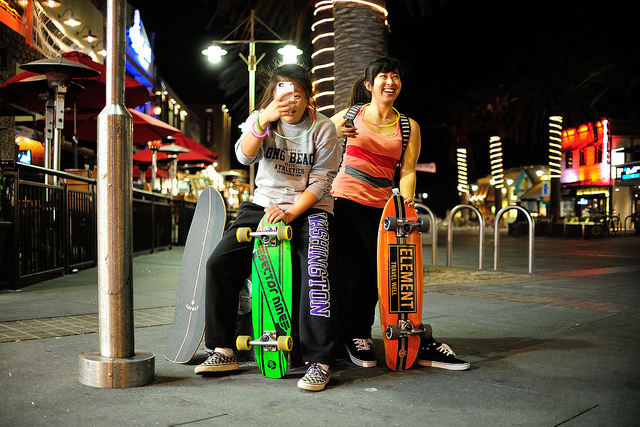Read all the text in this image. ONG BEA ELEMENT WASHINGTON SECTOR SECTOR 